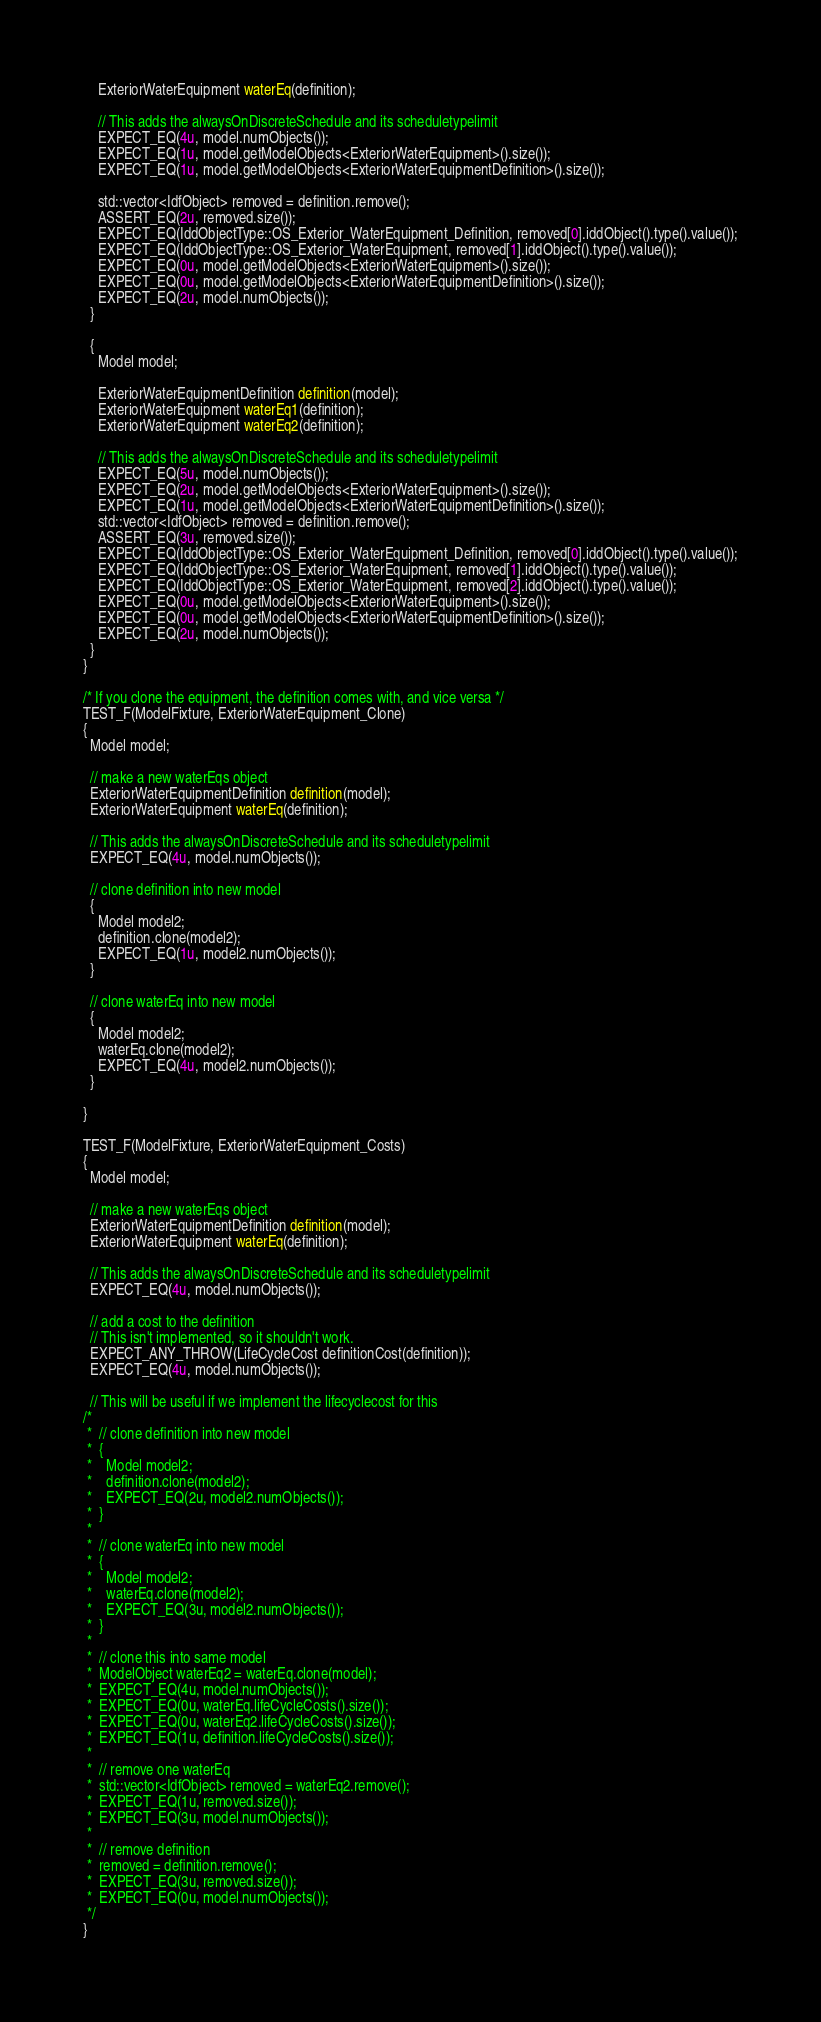<code> <loc_0><loc_0><loc_500><loc_500><_C++_>    ExteriorWaterEquipment waterEq(definition);

    // This adds the alwaysOnDiscreteSchedule and its scheduletypelimit
    EXPECT_EQ(4u, model.numObjects());
    EXPECT_EQ(1u, model.getModelObjects<ExteriorWaterEquipment>().size());
    EXPECT_EQ(1u, model.getModelObjects<ExteriorWaterEquipmentDefinition>().size());

    std::vector<IdfObject> removed = definition.remove();
    ASSERT_EQ(2u, removed.size());
    EXPECT_EQ(IddObjectType::OS_Exterior_WaterEquipment_Definition, removed[0].iddObject().type().value());
    EXPECT_EQ(IddObjectType::OS_Exterior_WaterEquipment, removed[1].iddObject().type().value());
    EXPECT_EQ(0u, model.getModelObjects<ExteriorWaterEquipment>().size());
    EXPECT_EQ(0u, model.getModelObjects<ExteriorWaterEquipmentDefinition>().size());
    EXPECT_EQ(2u, model.numObjects());
  }

  {
    Model model;

    ExteriorWaterEquipmentDefinition definition(model);
    ExteriorWaterEquipment waterEq1(definition);
    ExteriorWaterEquipment waterEq2(definition);

    // This adds the alwaysOnDiscreteSchedule and its scheduletypelimit
    EXPECT_EQ(5u, model.numObjects());
    EXPECT_EQ(2u, model.getModelObjects<ExteriorWaterEquipment>().size());
    EXPECT_EQ(1u, model.getModelObjects<ExteriorWaterEquipmentDefinition>().size());
    std::vector<IdfObject> removed = definition.remove();
    ASSERT_EQ(3u, removed.size());
    EXPECT_EQ(IddObjectType::OS_Exterior_WaterEquipment_Definition, removed[0].iddObject().type().value());
    EXPECT_EQ(IddObjectType::OS_Exterior_WaterEquipment, removed[1].iddObject().type().value());
    EXPECT_EQ(IddObjectType::OS_Exterior_WaterEquipment, removed[2].iddObject().type().value());
    EXPECT_EQ(0u, model.getModelObjects<ExteriorWaterEquipment>().size());
    EXPECT_EQ(0u, model.getModelObjects<ExteriorWaterEquipmentDefinition>().size());
    EXPECT_EQ(2u, model.numObjects());
  }
}

/* If you clone the equipment, the definition comes with, and vice versa */
TEST_F(ModelFixture, ExteriorWaterEquipment_Clone)
{
  Model model;

  // make a new waterEqs object
  ExteriorWaterEquipmentDefinition definition(model);
  ExteriorWaterEquipment waterEq(definition);

  // This adds the alwaysOnDiscreteSchedule and its scheduletypelimit
  EXPECT_EQ(4u, model.numObjects());

  // clone definition into new model
  {
    Model model2;
    definition.clone(model2);
    EXPECT_EQ(1u, model2.numObjects());
  }

  // clone waterEq into new model
  {
    Model model2;
    waterEq.clone(model2);
    EXPECT_EQ(4u, model2.numObjects());
  }

}

TEST_F(ModelFixture, ExteriorWaterEquipment_Costs)
{
  Model model;

  // make a new waterEqs object
  ExteriorWaterEquipmentDefinition definition(model);
  ExteriorWaterEquipment waterEq(definition);

  // This adds the alwaysOnDiscreteSchedule and its scheduletypelimit
  EXPECT_EQ(4u, model.numObjects());

  // add a cost to the definition
  // This isn't implemented, so it shouldn't work.
  EXPECT_ANY_THROW(LifeCycleCost definitionCost(definition));
  EXPECT_EQ(4u, model.numObjects());

  // This will be useful if we implement the lifecyclecost for this
/*
 *  // clone definition into new model
 *  {
 *    Model model2;
 *    definition.clone(model2);
 *    EXPECT_EQ(2u, model2.numObjects());
 *  }
 *
 *  // clone waterEq into new model
 *  {
 *    Model model2;
 *    waterEq.clone(model2);
 *    EXPECT_EQ(3u, model2.numObjects());
 *  }
 *
 *  // clone this into same model
 *  ModelObject waterEq2 = waterEq.clone(model);
 *  EXPECT_EQ(4u, model.numObjects());
 *  EXPECT_EQ(0u, waterEq.lifeCycleCosts().size());
 *  EXPECT_EQ(0u, waterEq2.lifeCycleCosts().size());
 *  EXPECT_EQ(1u, definition.lifeCycleCosts().size());
 *
 *  // remove one waterEq
 *  std::vector<IdfObject> removed = waterEq2.remove();
 *  EXPECT_EQ(1u, removed.size());
 *  EXPECT_EQ(3u, model.numObjects());
 *
 *  // remove definition
 *  removed = definition.remove();
 *  EXPECT_EQ(3u, removed.size());
 *  EXPECT_EQ(0u, model.numObjects());
 */
}
</code> 